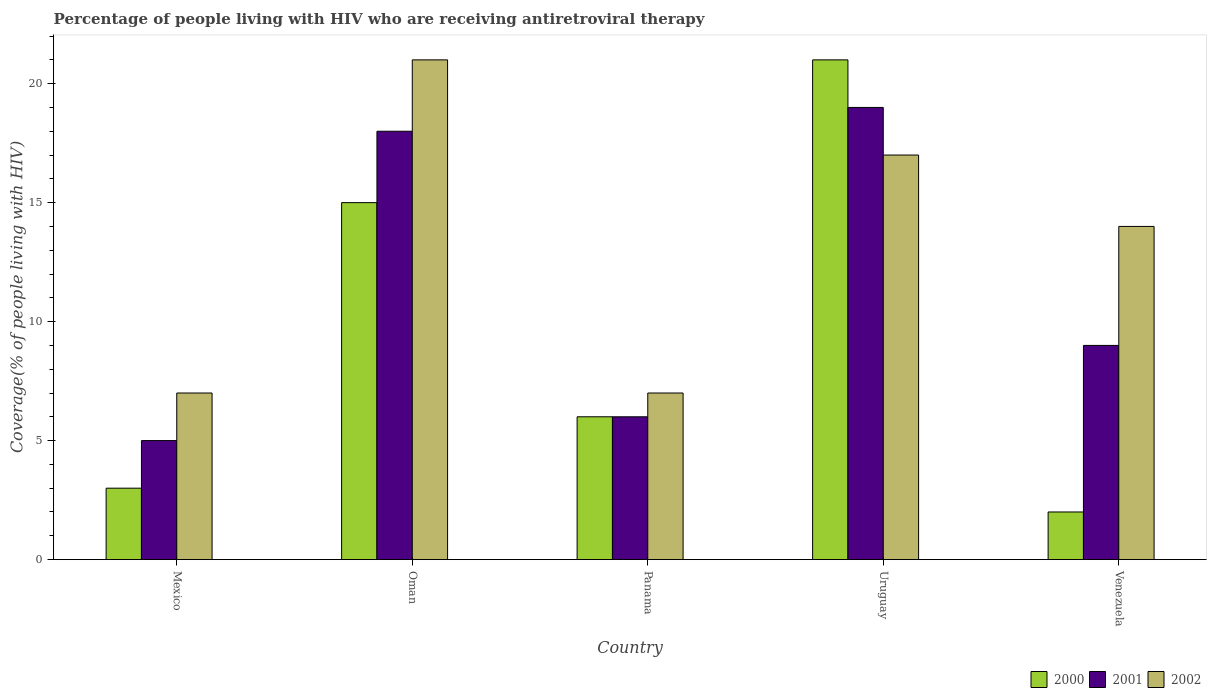Are the number of bars on each tick of the X-axis equal?
Your answer should be compact. Yes. How many bars are there on the 5th tick from the left?
Ensure brevity in your answer.  3. What is the label of the 4th group of bars from the left?
Ensure brevity in your answer.  Uruguay. In how many cases, is the number of bars for a given country not equal to the number of legend labels?
Ensure brevity in your answer.  0. Across all countries, what is the minimum percentage of the HIV infected people who are receiving antiretroviral therapy in 2002?
Provide a succinct answer. 7. In which country was the percentage of the HIV infected people who are receiving antiretroviral therapy in 2001 maximum?
Provide a succinct answer. Uruguay. What is the total percentage of the HIV infected people who are receiving antiretroviral therapy in 2001 in the graph?
Ensure brevity in your answer.  57. What is the difference between the percentage of the HIV infected people who are receiving antiretroviral therapy in 2000 in Uruguay and that in Venezuela?
Your answer should be compact. 19. What is the average percentage of the HIV infected people who are receiving antiretroviral therapy in 2000 per country?
Your answer should be very brief. 9.4. What is the difference between the percentage of the HIV infected people who are receiving antiretroviral therapy of/in 2001 and percentage of the HIV infected people who are receiving antiretroviral therapy of/in 2002 in Panama?
Your answer should be very brief. -1. What is the ratio of the percentage of the HIV infected people who are receiving antiretroviral therapy in 2001 in Mexico to that in Venezuela?
Your response must be concise. 0.56. Is the difference between the percentage of the HIV infected people who are receiving antiretroviral therapy in 2001 in Oman and Uruguay greater than the difference between the percentage of the HIV infected people who are receiving antiretroviral therapy in 2002 in Oman and Uruguay?
Provide a succinct answer. No. In how many countries, is the percentage of the HIV infected people who are receiving antiretroviral therapy in 2001 greater than the average percentage of the HIV infected people who are receiving antiretroviral therapy in 2001 taken over all countries?
Your answer should be very brief. 2. What does the 2nd bar from the left in Mexico represents?
Offer a very short reply. 2001. How many countries are there in the graph?
Your response must be concise. 5. Are the values on the major ticks of Y-axis written in scientific E-notation?
Your answer should be very brief. No. Does the graph contain grids?
Your answer should be compact. No. Where does the legend appear in the graph?
Make the answer very short. Bottom right. What is the title of the graph?
Your response must be concise. Percentage of people living with HIV who are receiving antiretroviral therapy. Does "1996" appear as one of the legend labels in the graph?
Offer a terse response. No. What is the label or title of the Y-axis?
Your answer should be very brief. Coverage(% of people living with HIV). What is the Coverage(% of people living with HIV) of 2002 in Mexico?
Offer a terse response. 7. What is the Coverage(% of people living with HIV) in 2000 in Oman?
Ensure brevity in your answer.  15. What is the Coverage(% of people living with HIV) of 2000 in Panama?
Ensure brevity in your answer.  6. What is the Coverage(% of people living with HIV) in 2002 in Panama?
Ensure brevity in your answer.  7. What is the Coverage(% of people living with HIV) of 2000 in Venezuela?
Offer a very short reply. 2. What is the Coverage(% of people living with HIV) in 2002 in Venezuela?
Offer a terse response. 14. Across all countries, what is the maximum Coverage(% of people living with HIV) of 2000?
Ensure brevity in your answer.  21. Across all countries, what is the maximum Coverage(% of people living with HIV) of 2001?
Ensure brevity in your answer.  19. Across all countries, what is the maximum Coverage(% of people living with HIV) of 2002?
Your answer should be compact. 21. What is the total Coverage(% of people living with HIV) in 2000 in the graph?
Provide a short and direct response. 47. What is the difference between the Coverage(% of people living with HIV) in 2001 in Mexico and that in Oman?
Keep it short and to the point. -13. What is the difference between the Coverage(% of people living with HIV) in 2002 in Mexico and that in Oman?
Offer a very short reply. -14. What is the difference between the Coverage(% of people living with HIV) in 2000 in Mexico and that in Panama?
Keep it short and to the point. -3. What is the difference between the Coverage(% of people living with HIV) in 2002 in Mexico and that in Panama?
Your answer should be compact. 0. What is the difference between the Coverage(% of people living with HIV) of 2000 in Mexico and that in Uruguay?
Offer a very short reply. -18. What is the difference between the Coverage(% of people living with HIV) of 2002 in Mexico and that in Uruguay?
Your answer should be compact. -10. What is the difference between the Coverage(% of people living with HIV) of 2000 in Mexico and that in Venezuela?
Your response must be concise. 1. What is the difference between the Coverage(% of people living with HIV) in 2001 in Mexico and that in Venezuela?
Your response must be concise. -4. What is the difference between the Coverage(% of people living with HIV) of 2000 in Oman and that in Panama?
Offer a very short reply. 9. What is the difference between the Coverage(% of people living with HIV) in 2000 in Oman and that in Uruguay?
Keep it short and to the point. -6. What is the difference between the Coverage(% of people living with HIV) in 2001 in Oman and that in Uruguay?
Give a very brief answer. -1. What is the difference between the Coverage(% of people living with HIV) in 2002 in Oman and that in Uruguay?
Make the answer very short. 4. What is the difference between the Coverage(% of people living with HIV) in 2000 in Panama and that in Uruguay?
Provide a short and direct response. -15. What is the difference between the Coverage(% of people living with HIV) of 2000 in Panama and that in Venezuela?
Provide a short and direct response. 4. What is the difference between the Coverage(% of people living with HIV) of 2001 in Panama and that in Venezuela?
Keep it short and to the point. -3. What is the difference between the Coverage(% of people living with HIV) in 2002 in Panama and that in Venezuela?
Keep it short and to the point. -7. What is the difference between the Coverage(% of people living with HIV) in 2000 in Uruguay and that in Venezuela?
Ensure brevity in your answer.  19. What is the difference between the Coverage(% of people living with HIV) in 2001 in Uruguay and that in Venezuela?
Ensure brevity in your answer.  10. What is the difference between the Coverage(% of people living with HIV) of 2000 in Mexico and the Coverage(% of people living with HIV) of 2001 in Oman?
Ensure brevity in your answer.  -15. What is the difference between the Coverage(% of people living with HIV) of 2000 in Mexico and the Coverage(% of people living with HIV) of 2002 in Oman?
Provide a short and direct response. -18. What is the difference between the Coverage(% of people living with HIV) in 2001 in Mexico and the Coverage(% of people living with HIV) in 2002 in Oman?
Ensure brevity in your answer.  -16. What is the difference between the Coverage(% of people living with HIV) of 2000 in Mexico and the Coverage(% of people living with HIV) of 2001 in Panama?
Your answer should be compact. -3. What is the difference between the Coverage(% of people living with HIV) in 2000 in Mexico and the Coverage(% of people living with HIV) in 2002 in Panama?
Your response must be concise. -4. What is the difference between the Coverage(% of people living with HIV) of 2001 in Mexico and the Coverage(% of people living with HIV) of 2002 in Panama?
Your response must be concise. -2. What is the difference between the Coverage(% of people living with HIV) of 2001 in Mexico and the Coverage(% of people living with HIV) of 2002 in Uruguay?
Offer a very short reply. -12. What is the difference between the Coverage(% of people living with HIV) of 2000 in Mexico and the Coverage(% of people living with HIV) of 2001 in Venezuela?
Keep it short and to the point. -6. What is the difference between the Coverage(% of people living with HIV) in 2000 in Mexico and the Coverage(% of people living with HIV) in 2002 in Venezuela?
Your response must be concise. -11. What is the difference between the Coverage(% of people living with HIV) in 2000 in Oman and the Coverage(% of people living with HIV) in 2001 in Panama?
Give a very brief answer. 9. What is the difference between the Coverage(% of people living with HIV) of 2000 in Oman and the Coverage(% of people living with HIV) of 2001 in Uruguay?
Your answer should be compact. -4. What is the difference between the Coverage(% of people living with HIV) in 2000 in Oman and the Coverage(% of people living with HIV) in 2002 in Uruguay?
Provide a short and direct response. -2. What is the difference between the Coverage(% of people living with HIV) in 2001 in Oman and the Coverage(% of people living with HIV) in 2002 in Uruguay?
Offer a terse response. 1. What is the difference between the Coverage(% of people living with HIV) in 2000 in Oman and the Coverage(% of people living with HIV) in 2001 in Venezuela?
Provide a succinct answer. 6. What is the difference between the Coverage(% of people living with HIV) in 2000 in Panama and the Coverage(% of people living with HIV) in 2002 in Uruguay?
Your answer should be compact. -11. What is the difference between the Coverage(% of people living with HIV) in 2001 in Panama and the Coverage(% of people living with HIV) in 2002 in Uruguay?
Your response must be concise. -11. What is the difference between the Coverage(% of people living with HIV) in 2000 in Uruguay and the Coverage(% of people living with HIV) in 2001 in Venezuela?
Give a very brief answer. 12. What is the difference between the Coverage(% of people living with HIV) of 2001 in Uruguay and the Coverage(% of people living with HIV) of 2002 in Venezuela?
Ensure brevity in your answer.  5. What is the average Coverage(% of people living with HIV) of 2001 per country?
Provide a short and direct response. 11.4. What is the average Coverage(% of people living with HIV) of 2002 per country?
Your response must be concise. 13.2. What is the difference between the Coverage(% of people living with HIV) of 2001 and Coverage(% of people living with HIV) of 2002 in Mexico?
Your answer should be very brief. -2. What is the difference between the Coverage(% of people living with HIV) of 2000 and Coverage(% of people living with HIV) of 2001 in Oman?
Offer a terse response. -3. What is the difference between the Coverage(% of people living with HIV) of 2000 and Coverage(% of people living with HIV) of 2002 in Oman?
Offer a very short reply. -6. What is the difference between the Coverage(% of people living with HIV) of 2000 and Coverage(% of people living with HIV) of 2002 in Panama?
Your answer should be very brief. -1. What is the difference between the Coverage(% of people living with HIV) in 2000 and Coverage(% of people living with HIV) in 2002 in Uruguay?
Your response must be concise. 4. What is the difference between the Coverage(% of people living with HIV) of 2000 and Coverage(% of people living with HIV) of 2001 in Venezuela?
Ensure brevity in your answer.  -7. What is the difference between the Coverage(% of people living with HIV) in 2000 and Coverage(% of people living with HIV) in 2002 in Venezuela?
Make the answer very short. -12. What is the difference between the Coverage(% of people living with HIV) of 2001 and Coverage(% of people living with HIV) of 2002 in Venezuela?
Keep it short and to the point. -5. What is the ratio of the Coverage(% of people living with HIV) of 2001 in Mexico to that in Oman?
Offer a very short reply. 0.28. What is the ratio of the Coverage(% of people living with HIV) in 2000 in Mexico to that in Panama?
Offer a terse response. 0.5. What is the ratio of the Coverage(% of people living with HIV) of 2002 in Mexico to that in Panama?
Provide a succinct answer. 1. What is the ratio of the Coverage(% of people living with HIV) in 2000 in Mexico to that in Uruguay?
Provide a short and direct response. 0.14. What is the ratio of the Coverage(% of people living with HIV) in 2001 in Mexico to that in Uruguay?
Offer a terse response. 0.26. What is the ratio of the Coverage(% of people living with HIV) of 2002 in Mexico to that in Uruguay?
Give a very brief answer. 0.41. What is the ratio of the Coverage(% of people living with HIV) of 2001 in Mexico to that in Venezuela?
Offer a very short reply. 0.56. What is the ratio of the Coverage(% of people living with HIV) of 2001 in Oman to that in Panama?
Provide a short and direct response. 3. What is the ratio of the Coverage(% of people living with HIV) of 2002 in Oman to that in Panama?
Your answer should be compact. 3. What is the ratio of the Coverage(% of people living with HIV) of 2000 in Oman to that in Uruguay?
Your response must be concise. 0.71. What is the ratio of the Coverage(% of people living with HIV) of 2002 in Oman to that in Uruguay?
Your answer should be very brief. 1.24. What is the ratio of the Coverage(% of people living with HIV) of 2002 in Oman to that in Venezuela?
Your answer should be compact. 1.5. What is the ratio of the Coverage(% of people living with HIV) in 2000 in Panama to that in Uruguay?
Provide a succinct answer. 0.29. What is the ratio of the Coverage(% of people living with HIV) of 2001 in Panama to that in Uruguay?
Make the answer very short. 0.32. What is the ratio of the Coverage(% of people living with HIV) in 2002 in Panama to that in Uruguay?
Make the answer very short. 0.41. What is the ratio of the Coverage(% of people living with HIV) in 2000 in Panama to that in Venezuela?
Provide a short and direct response. 3. What is the ratio of the Coverage(% of people living with HIV) of 2001 in Uruguay to that in Venezuela?
Provide a short and direct response. 2.11. What is the ratio of the Coverage(% of people living with HIV) of 2002 in Uruguay to that in Venezuela?
Make the answer very short. 1.21. What is the difference between the highest and the second highest Coverage(% of people living with HIV) of 2001?
Your answer should be compact. 1. What is the difference between the highest and the lowest Coverage(% of people living with HIV) in 2000?
Your response must be concise. 19. What is the difference between the highest and the lowest Coverage(% of people living with HIV) in 2002?
Make the answer very short. 14. 